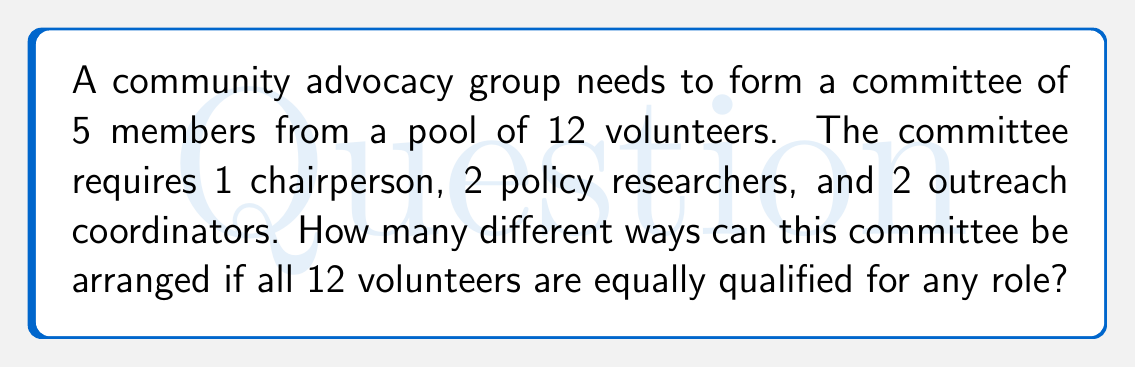Can you solve this math problem? Let's break this down step-by-step:

1) First, we need to choose 5 people out of 12 for the committee. This can be done in $\binom{12}{5}$ ways.

2) Once we have chosen 5 people, we need to assign roles:
   - 1 person needs to be chosen as chairperson
   - 2 people need to be assigned as policy researchers
   - 2 people need to be assigned as outreach coordinators

3) This is a permutation problem. We can calculate it as follows:
   - Ways to choose 1 chairperson: $\binom{5}{1} = 5$
   - Ways to choose 2 policy researchers from remaining 4: $\binom{4}{2} = 6$
   - The last 2 automatically become outreach coordinators

4) By the multiplication principle, the total number of ways to arrange the committee is:

   $$\binom{12}{5} \cdot 5 \cdot 6$$

5) Let's calculate:
   $\binom{12}{5} = \frac{12!}{5!(12-5)!} = \frac{12!}{5!7!} = 792$

6) Therefore, the total number of arrangements is:

   $$792 \cdot 5 \cdot 6 = 23,760$$
Answer: 23,760 